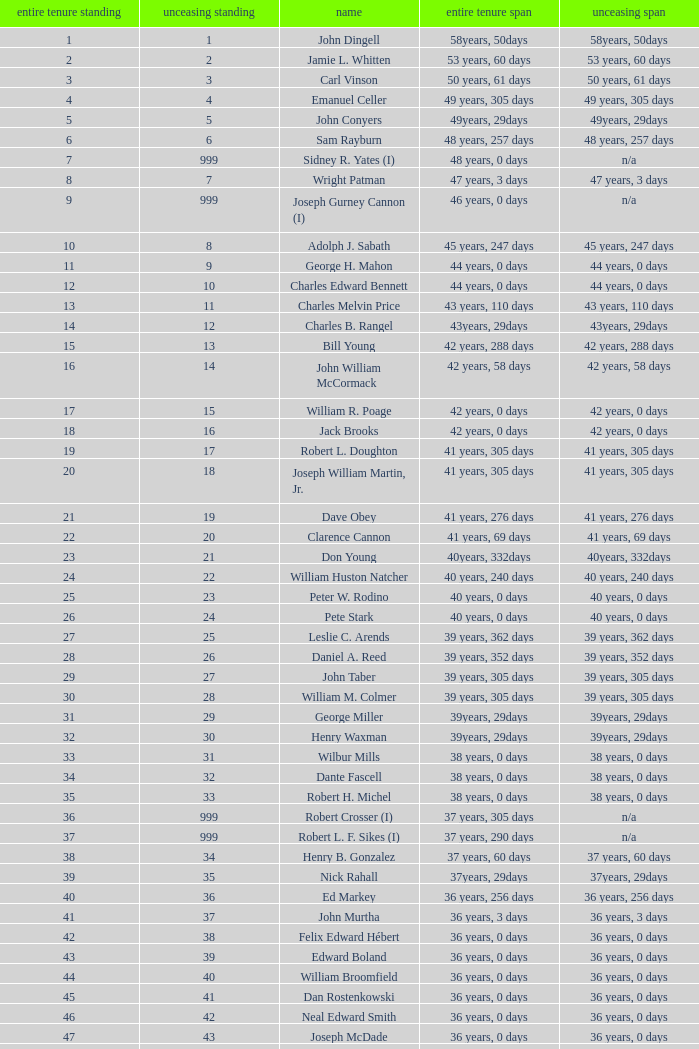Who has a total tenure time and uninterrupted time of 36 years, 0 days, as well as a total tenure rank of 49? James Oberstar. 